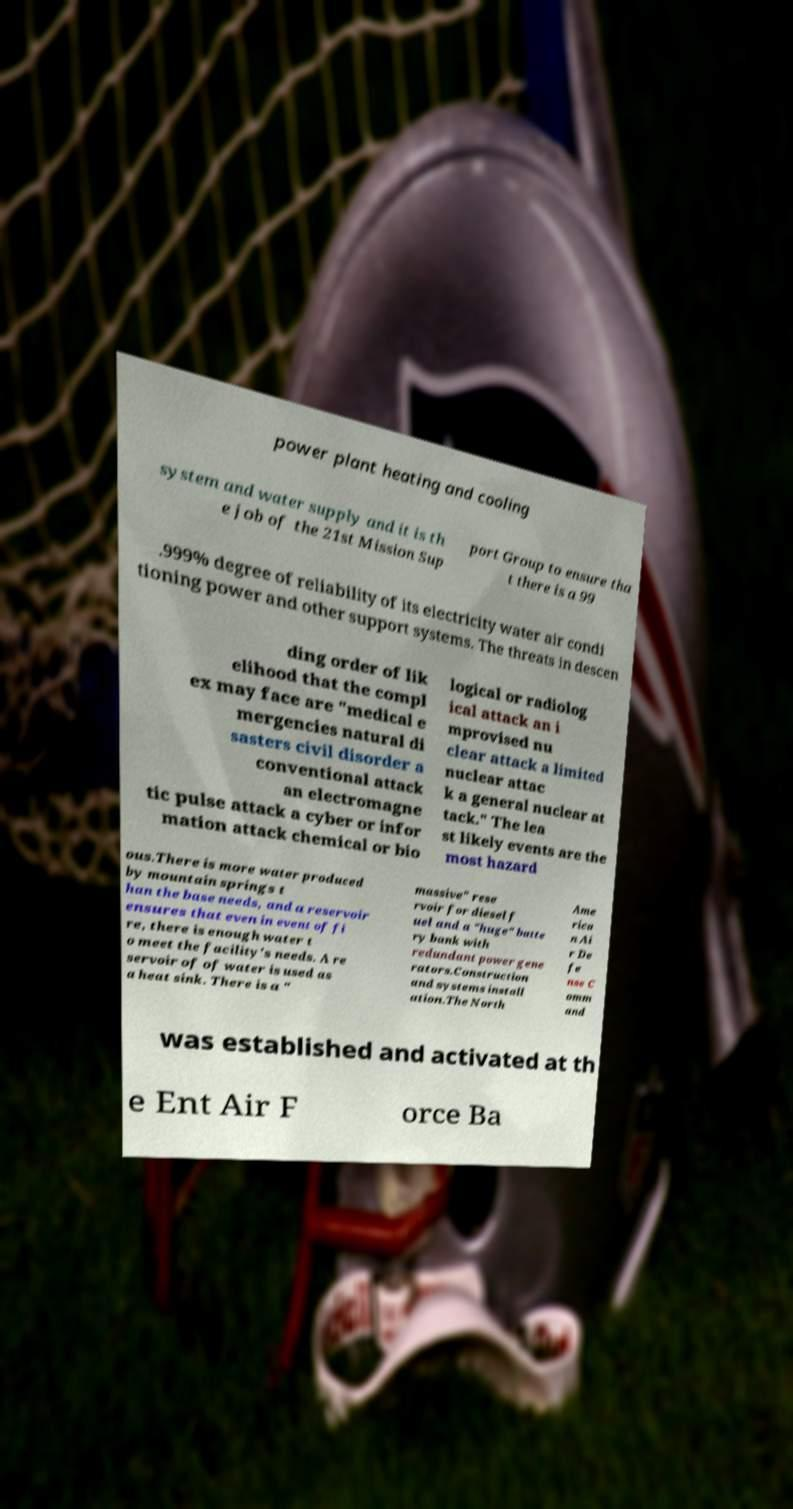Can you accurately transcribe the text from the provided image for me? power plant heating and cooling system and water supply and it is th e job of the 21st Mission Sup port Group to ensure tha t there is a 99 .999% degree of reliability of its electricity water air condi tioning power and other support systems. The threats in descen ding order of lik elihood that the compl ex may face are "medical e mergencies natural di sasters civil disorder a conventional attack an electromagne tic pulse attack a cyber or infor mation attack chemical or bio logical or radiolog ical attack an i mprovised nu clear attack a limited nuclear attac k a general nuclear at tack." The lea st likely events are the most hazard ous.There is more water produced by mountain springs t han the base needs, and a reservoir ensures that even in event of fi re, there is enough water t o meet the facility's needs. A re servoir of of water is used as a heat sink. There is a " massive" rese rvoir for diesel f uel and a "huge" batte ry bank with redundant power gene rators.Construction and systems install ation.The North Ame rica n Ai r De fe nse C omm and was established and activated at th e Ent Air F orce Ba 